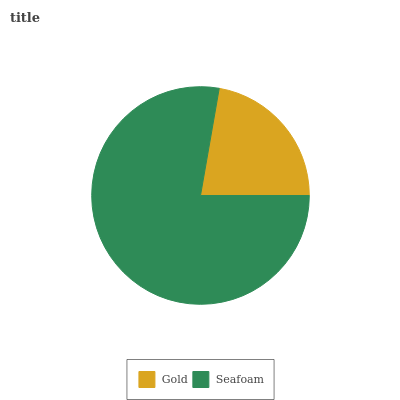Is Gold the minimum?
Answer yes or no. Yes. Is Seafoam the maximum?
Answer yes or no. Yes. Is Seafoam the minimum?
Answer yes or no. No. Is Seafoam greater than Gold?
Answer yes or no. Yes. Is Gold less than Seafoam?
Answer yes or no. Yes. Is Gold greater than Seafoam?
Answer yes or no. No. Is Seafoam less than Gold?
Answer yes or no. No. Is Seafoam the high median?
Answer yes or no. Yes. Is Gold the low median?
Answer yes or no. Yes. Is Gold the high median?
Answer yes or no. No. Is Seafoam the low median?
Answer yes or no. No. 